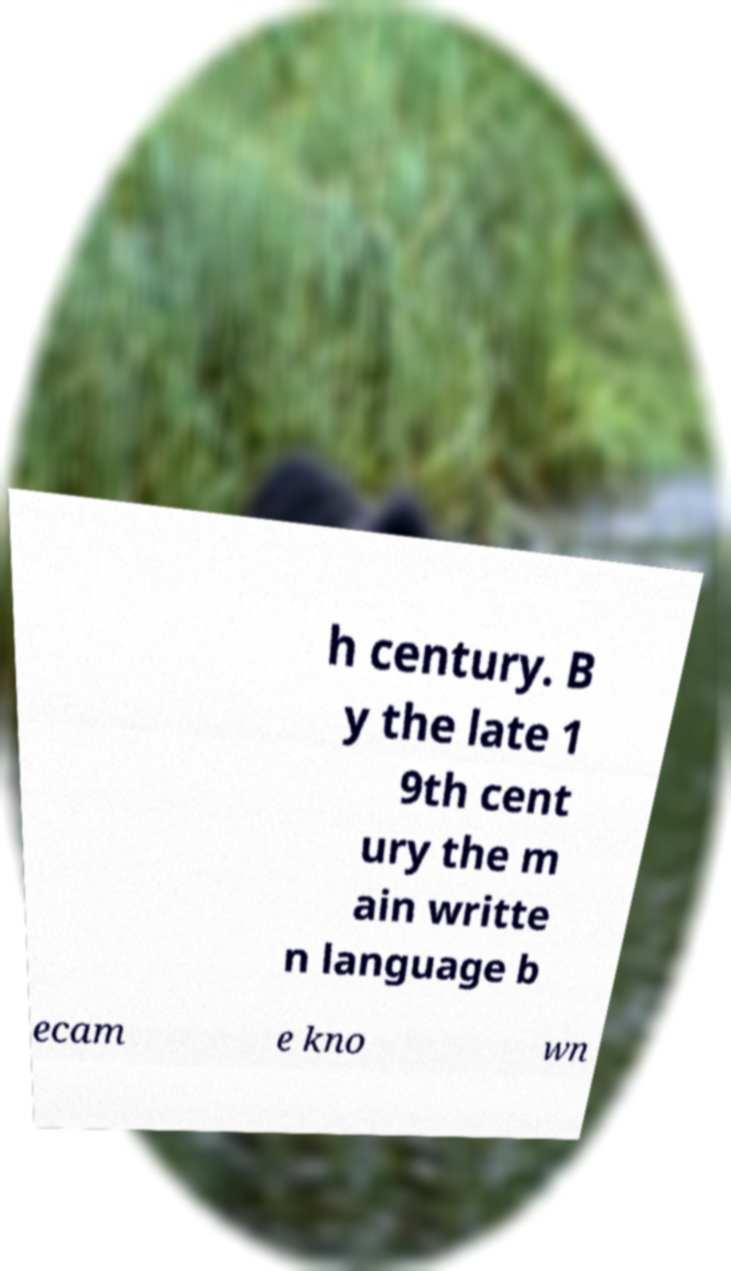Can you accurately transcribe the text from the provided image for me? h century. B y the late 1 9th cent ury the m ain writte n language b ecam e kno wn 